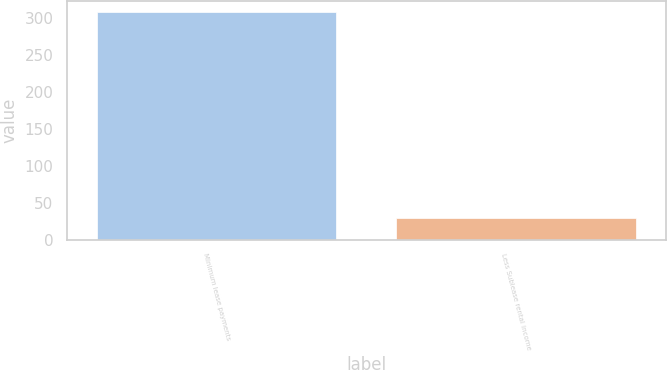<chart> <loc_0><loc_0><loc_500><loc_500><bar_chart><fcel>Minimum lease payments<fcel>Less Sublease rental income<nl><fcel>308<fcel>30<nl></chart> 